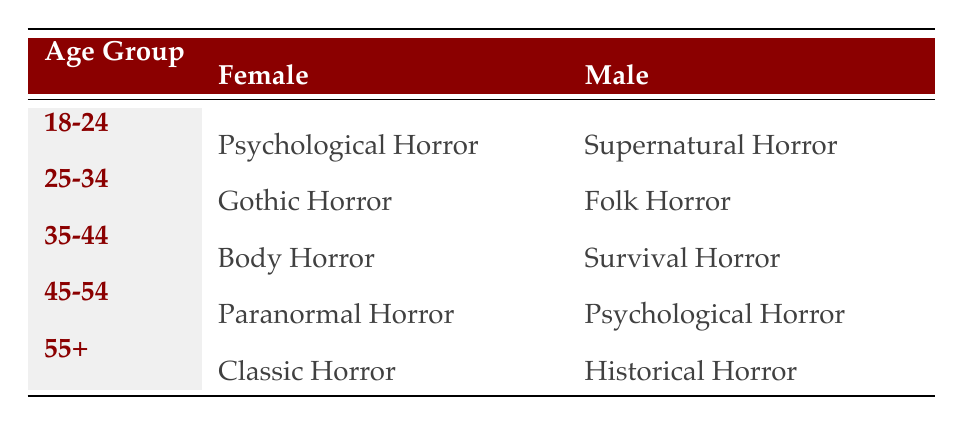What is the preferred horror motif for females aged 45-54? Referring to the table, the row for the age group 45-54 and the female column shows "Paranormal Horror" as the preferred motif for this demographic.
Answer: Paranormal Horror Which horror motif do males aged 55 and older prefer? The table lists the row for age group 55+. Referring to the male column, it indicates that the preferred motif is "Historical Horror."
Answer: Historical Horror How many different horror motifs are preferred by females compared to males in the 35-44 age group? For females aged 35-44, the preferred motif is "Body Horror." For males in the same age group, it is "Survival Horror." Thus, there are two different motifs presented; one for each gender in that age group.
Answer: 2 Is Gothic Horror preferred by any males in the age groups listed? Looking through the table, Gothic Horror is only listed under the female column for the 25-34 age group, with no occurrence in the male section. Therefore, the statement is false.
Answer: No What age group prefers Psychological Horror as their main motif from both genders? Examining the table, "Psychological Horror" appears once for females aged 18-24 and once for males aged 45-54. Therefore, there are two separate age groups that prefer this motif: 18-24 (female) and 45-54 (male).
Answer: 2 age groups 